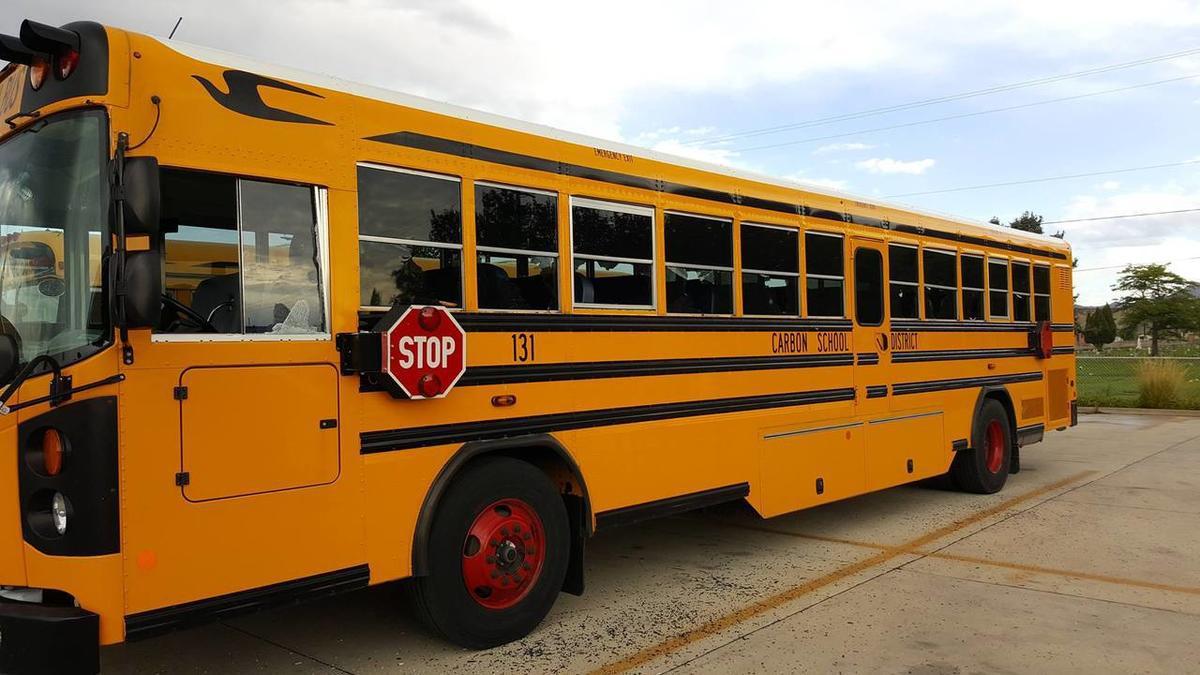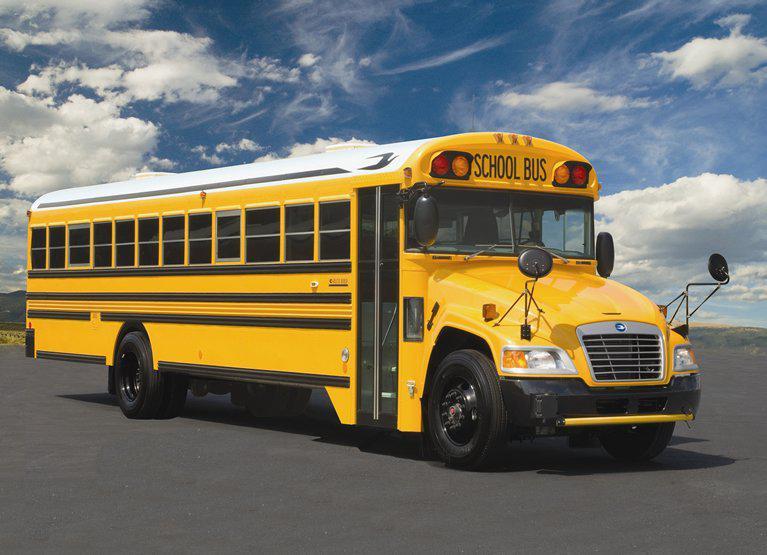The first image is the image on the left, the second image is the image on the right. Analyze the images presented: Is the assertion "The buses on the left and right face opposite directions, and one has a flat front while the other has a hood that projects forward." valid? Answer yes or no. Yes. 